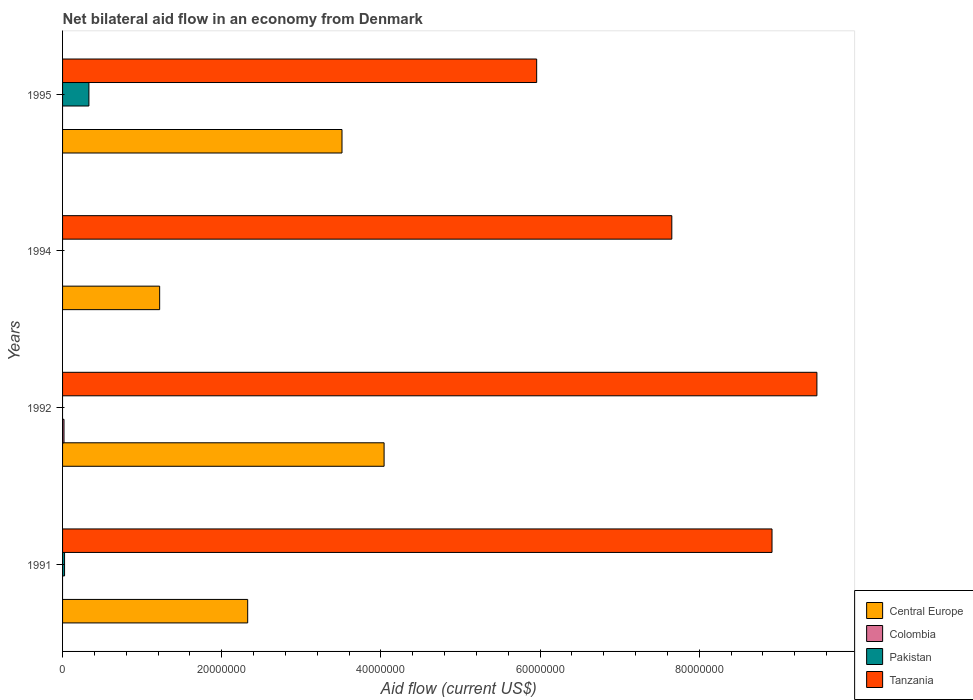How many different coloured bars are there?
Your answer should be compact. 4. Are the number of bars per tick equal to the number of legend labels?
Keep it short and to the point. No. How many bars are there on the 1st tick from the top?
Your answer should be very brief. 3. What is the label of the 1st group of bars from the top?
Give a very brief answer. 1995. What is the net bilateral aid flow in Tanzania in 1992?
Your answer should be compact. 9.48e+07. Across all years, what is the maximum net bilateral aid flow in Central Europe?
Your answer should be compact. 4.04e+07. Across all years, what is the minimum net bilateral aid flow in Colombia?
Ensure brevity in your answer.  0. What is the total net bilateral aid flow in Colombia in the graph?
Provide a succinct answer. 1.80e+05. What is the difference between the net bilateral aid flow in Central Europe in 1994 and that in 1995?
Keep it short and to the point. -2.29e+07. What is the difference between the net bilateral aid flow in Colombia in 1992 and the net bilateral aid flow in Central Europe in 1991?
Give a very brief answer. -2.31e+07. What is the average net bilateral aid flow in Central Europe per year?
Offer a very short reply. 2.77e+07. In the year 1991, what is the difference between the net bilateral aid flow in Pakistan and net bilateral aid flow in Tanzania?
Ensure brevity in your answer.  -8.89e+07. In how many years, is the net bilateral aid flow in Tanzania greater than 12000000 US$?
Offer a terse response. 4. Is the difference between the net bilateral aid flow in Pakistan in 1991 and 1995 greater than the difference between the net bilateral aid flow in Tanzania in 1991 and 1995?
Provide a short and direct response. No. What is the difference between the highest and the second highest net bilateral aid flow in Tanzania?
Provide a short and direct response. 5.64e+06. What is the difference between the highest and the lowest net bilateral aid flow in Tanzania?
Keep it short and to the point. 3.52e+07. In how many years, is the net bilateral aid flow in Colombia greater than the average net bilateral aid flow in Colombia taken over all years?
Offer a terse response. 1. What is the difference between two consecutive major ticks on the X-axis?
Offer a terse response. 2.00e+07. How many legend labels are there?
Make the answer very short. 4. What is the title of the graph?
Make the answer very short. Net bilateral aid flow in an economy from Denmark. What is the label or title of the X-axis?
Your answer should be compact. Aid flow (current US$). What is the label or title of the Y-axis?
Your answer should be compact. Years. What is the Aid flow (current US$) in Central Europe in 1991?
Provide a short and direct response. 2.33e+07. What is the Aid flow (current US$) in Colombia in 1991?
Offer a very short reply. 0. What is the Aid flow (current US$) in Pakistan in 1991?
Your answer should be compact. 2.50e+05. What is the Aid flow (current US$) of Tanzania in 1991?
Give a very brief answer. 8.91e+07. What is the Aid flow (current US$) in Central Europe in 1992?
Provide a succinct answer. 4.04e+07. What is the Aid flow (current US$) of Colombia in 1992?
Make the answer very short. 1.80e+05. What is the Aid flow (current US$) of Tanzania in 1992?
Provide a short and direct response. 9.48e+07. What is the Aid flow (current US$) in Central Europe in 1994?
Keep it short and to the point. 1.22e+07. What is the Aid flow (current US$) in Colombia in 1994?
Your answer should be very brief. 0. What is the Aid flow (current US$) of Tanzania in 1994?
Your answer should be compact. 7.66e+07. What is the Aid flow (current US$) in Central Europe in 1995?
Your answer should be very brief. 3.51e+07. What is the Aid flow (current US$) of Colombia in 1995?
Offer a very short reply. 0. What is the Aid flow (current US$) of Pakistan in 1995?
Your answer should be compact. 3.31e+06. What is the Aid flow (current US$) in Tanzania in 1995?
Keep it short and to the point. 5.96e+07. Across all years, what is the maximum Aid flow (current US$) of Central Europe?
Provide a succinct answer. 4.04e+07. Across all years, what is the maximum Aid flow (current US$) in Pakistan?
Your answer should be very brief. 3.31e+06. Across all years, what is the maximum Aid flow (current US$) in Tanzania?
Ensure brevity in your answer.  9.48e+07. Across all years, what is the minimum Aid flow (current US$) of Central Europe?
Ensure brevity in your answer.  1.22e+07. Across all years, what is the minimum Aid flow (current US$) in Colombia?
Make the answer very short. 0. Across all years, what is the minimum Aid flow (current US$) in Tanzania?
Make the answer very short. 5.96e+07. What is the total Aid flow (current US$) in Central Europe in the graph?
Give a very brief answer. 1.11e+08. What is the total Aid flow (current US$) of Colombia in the graph?
Provide a succinct answer. 1.80e+05. What is the total Aid flow (current US$) of Pakistan in the graph?
Keep it short and to the point. 3.56e+06. What is the total Aid flow (current US$) in Tanzania in the graph?
Make the answer very short. 3.20e+08. What is the difference between the Aid flow (current US$) in Central Europe in 1991 and that in 1992?
Give a very brief answer. -1.71e+07. What is the difference between the Aid flow (current US$) of Tanzania in 1991 and that in 1992?
Make the answer very short. -5.64e+06. What is the difference between the Aid flow (current US$) in Central Europe in 1991 and that in 1994?
Your answer should be very brief. 1.11e+07. What is the difference between the Aid flow (current US$) in Tanzania in 1991 and that in 1994?
Your answer should be very brief. 1.26e+07. What is the difference between the Aid flow (current US$) of Central Europe in 1991 and that in 1995?
Provide a short and direct response. -1.18e+07. What is the difference between the Aid flow (current US$) of Pakistan in 1991 and that in 1995?
Your answer should be very brief. -3.06e+06. What is the difference between the Aid flow (current US$) of Tanzania in 1991 and that in 1995?
Offer a very short reply. 2.96e+07. What is the difference between the Aid flow (current US$) in Central Europe in 1992 and that in 1994?
Provide a succinct answer. 2.82e+07. What is the difference between the Aid flow (current US$) in Tanzania in 1992 and that in 1994?
Make the answer very short. 1.82e+07. What is the difference between the Aid flow (current US$) of Central Europe in 1992 and that in 1995?
Offer a very short reply. 5.29e+06. What is the difference between the Aid flow (current US$) of Tanzania in 1992 and that in 1995?
Your answer should be very brief. 3.52e+07. What is the difference between the Aid flow (current US$) of Central Europe in 1994 and that in 1995?
Make the answer very short. -2.29e+07. What is the difference between the Aid flow (current US$) of Tanzania in 1994 and that in 1995?
Make the answer very short. 1.70e+07. What is the difference between the Aid flow (current US$) of Central Europe in 1991 and the Aid flow (current US$) of Colombia in 1992?
Your answer should be very brief. 2.31e+07. What is the difference between the Aid flow (current US$) in Central Europe in 1991 and the Aid flow (current US$) in Tanzania in 1992?
Ensure brevity in your answer.  -7.15e+07. What is the difference between the Aid flow (current US$) of Pakistan in 1991 and the Aid flow (current US$) of Tanzania in 1992?
Your answer should be very brief. -9.45e+07. What is the difference between the Aid flow (current US$) in Central Europe in 1991 and the Aid flow (current US$) in Tanzania in 1994?
Your response must be concise. -5.33e+07. What is the difference between the Aid flow (current US$) in Pakistan in 1991 and the Aid flow (current US$) in Tanzania in 1994?
Your response must be concise. -7.63e+07. What is the difference between the Aid flow (current US$) of Central Europe in 1991 and the Aid flow (current US$) of Pakistan in 1995?
Ensure brevity in your answer.  2.00e+07. What is the difference between the Aid flow (current US$) in Central Europe in 1991 and the Aid flow (current US$) in Tanzania in 1995?
Give a very brief answer. -3.63e+07. What is the difference between the Aid flow (current US$) in Pakistan in 1991 and the Aid flow (current US$) in Tanzania in 1995?
Ensure brevity in your answer.  -5.93e+07. What is the difference between the Aid flow (current US$) in Central Europe in 1992 and the Aid flow (current US$) in Tanzania in 1994?
Offer a terse response. -3.62e+07. What is the difference between the Aid flow (current US$) of Colombia in 1992 and the Aid flow (current US$) of Tanzania in 1994?
Give a very brief answer. -7.64e+07. What is the difference between the Aid flow (current US$) in Central Europe in 1992 and the Aid flow (current US$) in Pakistan in 1995?
Provide a short and direct response. 3.71e+07. What is the difference between the Aid flow (current US$) in Central Europe in 1992 and the Aid flow (current US$) in Tanzania in 1995?
Your response must be concise. -1.92e+07. What is the difference between the Aid flow (current US$) in Colombia in 1992 and the Aid flow (current US$) in Pakistan in 1995?
Provide a succinct answer. -3.13e+06. What is the difference between the Aid flow (current US$) in Colombia in 1992 and the Aid flow (current US$) in Tanzania in 1995?
Give a very brief answer. -5.94e+07. What is the difference between the Aid flow (current US$) of Central Europe in 1994 and the Aid flow (current US$) of Pakistan in 1995?
Ensure brevity in your answer.  8.89e+06. What is the difference between the Aid flow (current US$) in Central Europe in 1994 and the Aid flow (current US$) in Tanzania in 1995?
Make the answer very short. -4.74e+07. What is the average Aid flow (current US$) in Central Europe per year?
Your response must be concise. 2.77e+07. What is the average Aid flow (current US$) of Colombia per year?
Provide a succinct answer. 4.50e+04. What is the average Aid flow (current US$) in Pakistan per year?
Your answer should be compact. 8.90e+05. What is the average Aid flow (current US$) in Tanzania per year?
Keep it short and to the point. 8.00e+07. In the year 1991, what is the difference between the Aid flow (current US$) in Central Europe and Aid flow (current US$) in Pakistan?
Keep it short and to the point. 2.30e+07. In the year 1991, what is the difference between the Aid flow (current US$) of Central Europe and Aid flow (current US$) of Tanzania?
Your answer should be very brief. -6.59e+07. In the year 1991, what is the difference between the Aid flow (current US$) in Pakistan and Aid flow (current US$) in Tanzania?
Provide a short and direct response. -8.89e+07. In the year 1992, what is the difference between the Aid flow (current US$) of Central Europe and Aid flow (current US$) of Colombia?
Your response must be concise. 4.02e+07. In the year 1992, what is the difference between the Aid flow (current US$) in Central Europe and Aid flow (current US$) in Tanzania?
Offer a very short reply. -5.44e+07. In the year 1992, what is the difference between the Aid flow (current US$) in Colombia and Aid flow (current US$) in Tanzania?
Give a very brief answer. -9.46e+07. In the year 1994, what is the difference between the Aid flow (current US$) in Central Europe and Aid flow (current US$) in Tanzania?
Provide a succinct answer. -6.44e+07. In the year 1995, what is the difference between the Aid flow (current US$) of Central Europe and Aid flow (current US$) of Pakistan?
Your answer should be very brief. 3.18e+07. In the year 1995, what is the difference between the Aid flow (current US$) of Central Europe and Aid flow (current US$) of Tanzania?
Your answer should be very brief. -2.45e+07. In the year 1995, what is the difference between the Aid flow (current US$) in Pakistan and Aid flow (current US$) in Tanzania?
Make the answer very short. -5.63e+07. What is the ratio of the Aid flow (current US$) in Central Europe in 1991 to that in 1992?
Your answer should be very brief. 0.58. What is the ratio of the Aid flow (current US$) in Tanzania in 1991 to that in 1992?
Your answer should be compact. 0.94. What is the ratio of the Aid flow (current US$) of Central Europe in 1991 to that in 1994?
Keep it short and to the point. 1.91. What is the ratio of the Aid flow (current US$) in Tanzania in 1991 to that in 1994?
Give a very brief answer. 1.16. What is the ratio of the Aid flow (current US$) of Central Europe in 1991 to that in 1995?
Ensure brevity in your answer.  0.66. What is the ratio of the Aid flow (current US$) in Pakistan in 1991 to that in 1995?
Your answer should be compact. 0.08. What is the ratio of the Aid flow (current US$) of Tanzania in 1991 to that in 1995?
Keep it short and to the point. 1.5. What is the ratio of the Aid flow (current US$) of Central Europe in 1992 to that in 1994?
Offer a terse response. 3.31. What is the ratio of the Aid flow (current US$) of Tanzania in 1992 to that in 1994?
Provide a succinct answer. 1.24. What is the ratio of the Aid flow (current US$) of Central Europe in 1992 to that in 1995?
Ensure brevity in your answer.  1.15. What is the ratio of the Aid flow (current US$) of Tanzania in 1992 to that in 1995?
Make the answer very short. 1.59. What is the ratio of the Aid flow (current US$) of Central Europe in 1994 to that in 1995?
Ensure brevity in your answer.  0.35. What is the ratio of the Aid flow (current US$) in Tanzania in 1994 to that in 1995?
Offer a terse response. 1.28. What is the difference between the highest and the second highest Aid flow (current US$) in Central Europe?
Ensure brevity in your answer.  5.29e+06. What is the difference between the highest and the second highest Aid flow (current US$) of Tanzania?
Give a very brief answer. 5.64e+06. What is the difference between the highest and the lowest Aid flow (current US$) in Central Europe?
Keep it short and to the point. 2.82e+07. What is the difference between the highest and the lowest Aid flow (current US$) in Colombia?
Ensure brevity in your answer.  1.80e+05. What is the difference between the highest and the lowest Aid flow (current US$) of Pakistan?
Your answer should be compact. 3.31e+06. What is the difference between the highest and the lowest Aid flow (current US$) of Tanzania?
Your answer should be compact. 3.52e+07. 